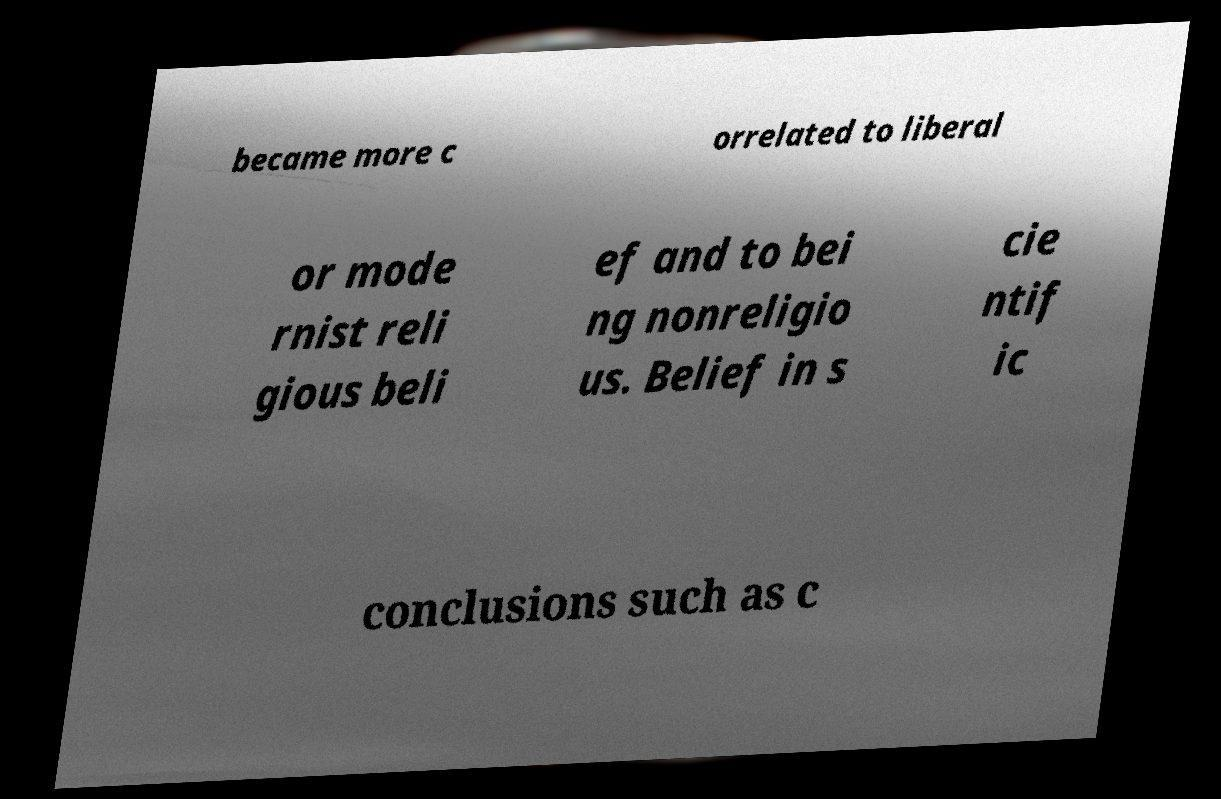What messages or text are displayed in this image? I need them in a readable, typed format. became more c orrelated to liberal or mode rnist reli gious beli ef and to bei ng nonreligio us. Belief in s cie ntif ic conclusions such as c 